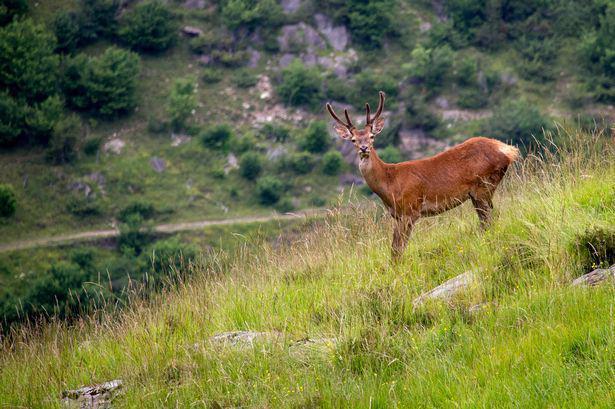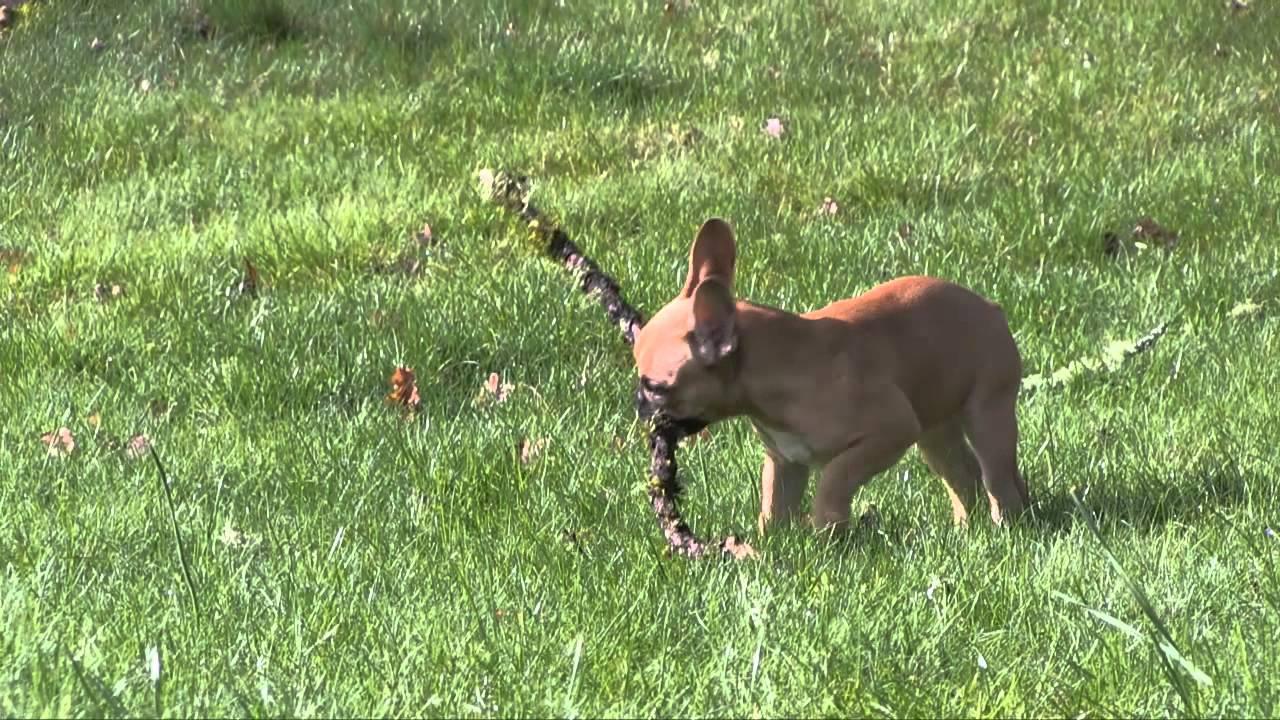The first image is the image on the left, the second image is the image on the right. Considering the images on both sides, is "Each picture includes more than one mammal." valid? Answer yes or no. No. The first image is the image on the left, the second image is the image on the right. For the images displayed, is the sentence "A total of one French Bulldog has something in its mouth." factually correct? Answer yes or no. Yes. 